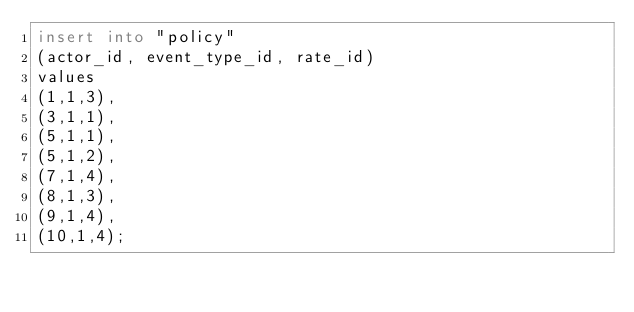<code> <loc_0><loc_0><loc_500><loc_500><_SQL_>insert into "policy"
(actor_id, event_type_id, rate_id)
values
(1,1,3),
(3,1,1),
(5,1,1),
(5,1,2),
(7,1,4),
(8,1,3),
(9,1,4),
(10,1,4);</code> 